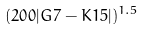<formula> <loc_0><loc_0><loc_500><loc_500>( 2 0 0 | G 7 - K 1 5 | ) ^ { 1 . 5 }</formula> 